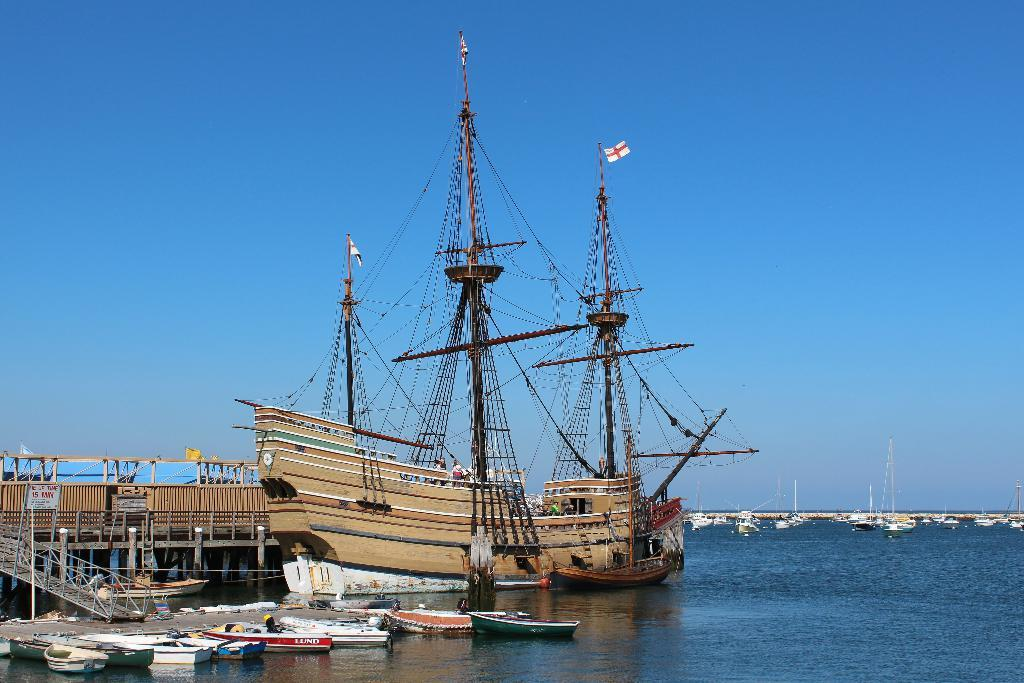What type of vehicles can be seen in the water in the image? There are boats and ships in the water in the image. What material are the rods visible in the image made of? The rods visible in the image are made of metal. How many pets can be seen on the boats in the image? There are no pets visible in the image; it only shows boats, ships, and metal rods. 